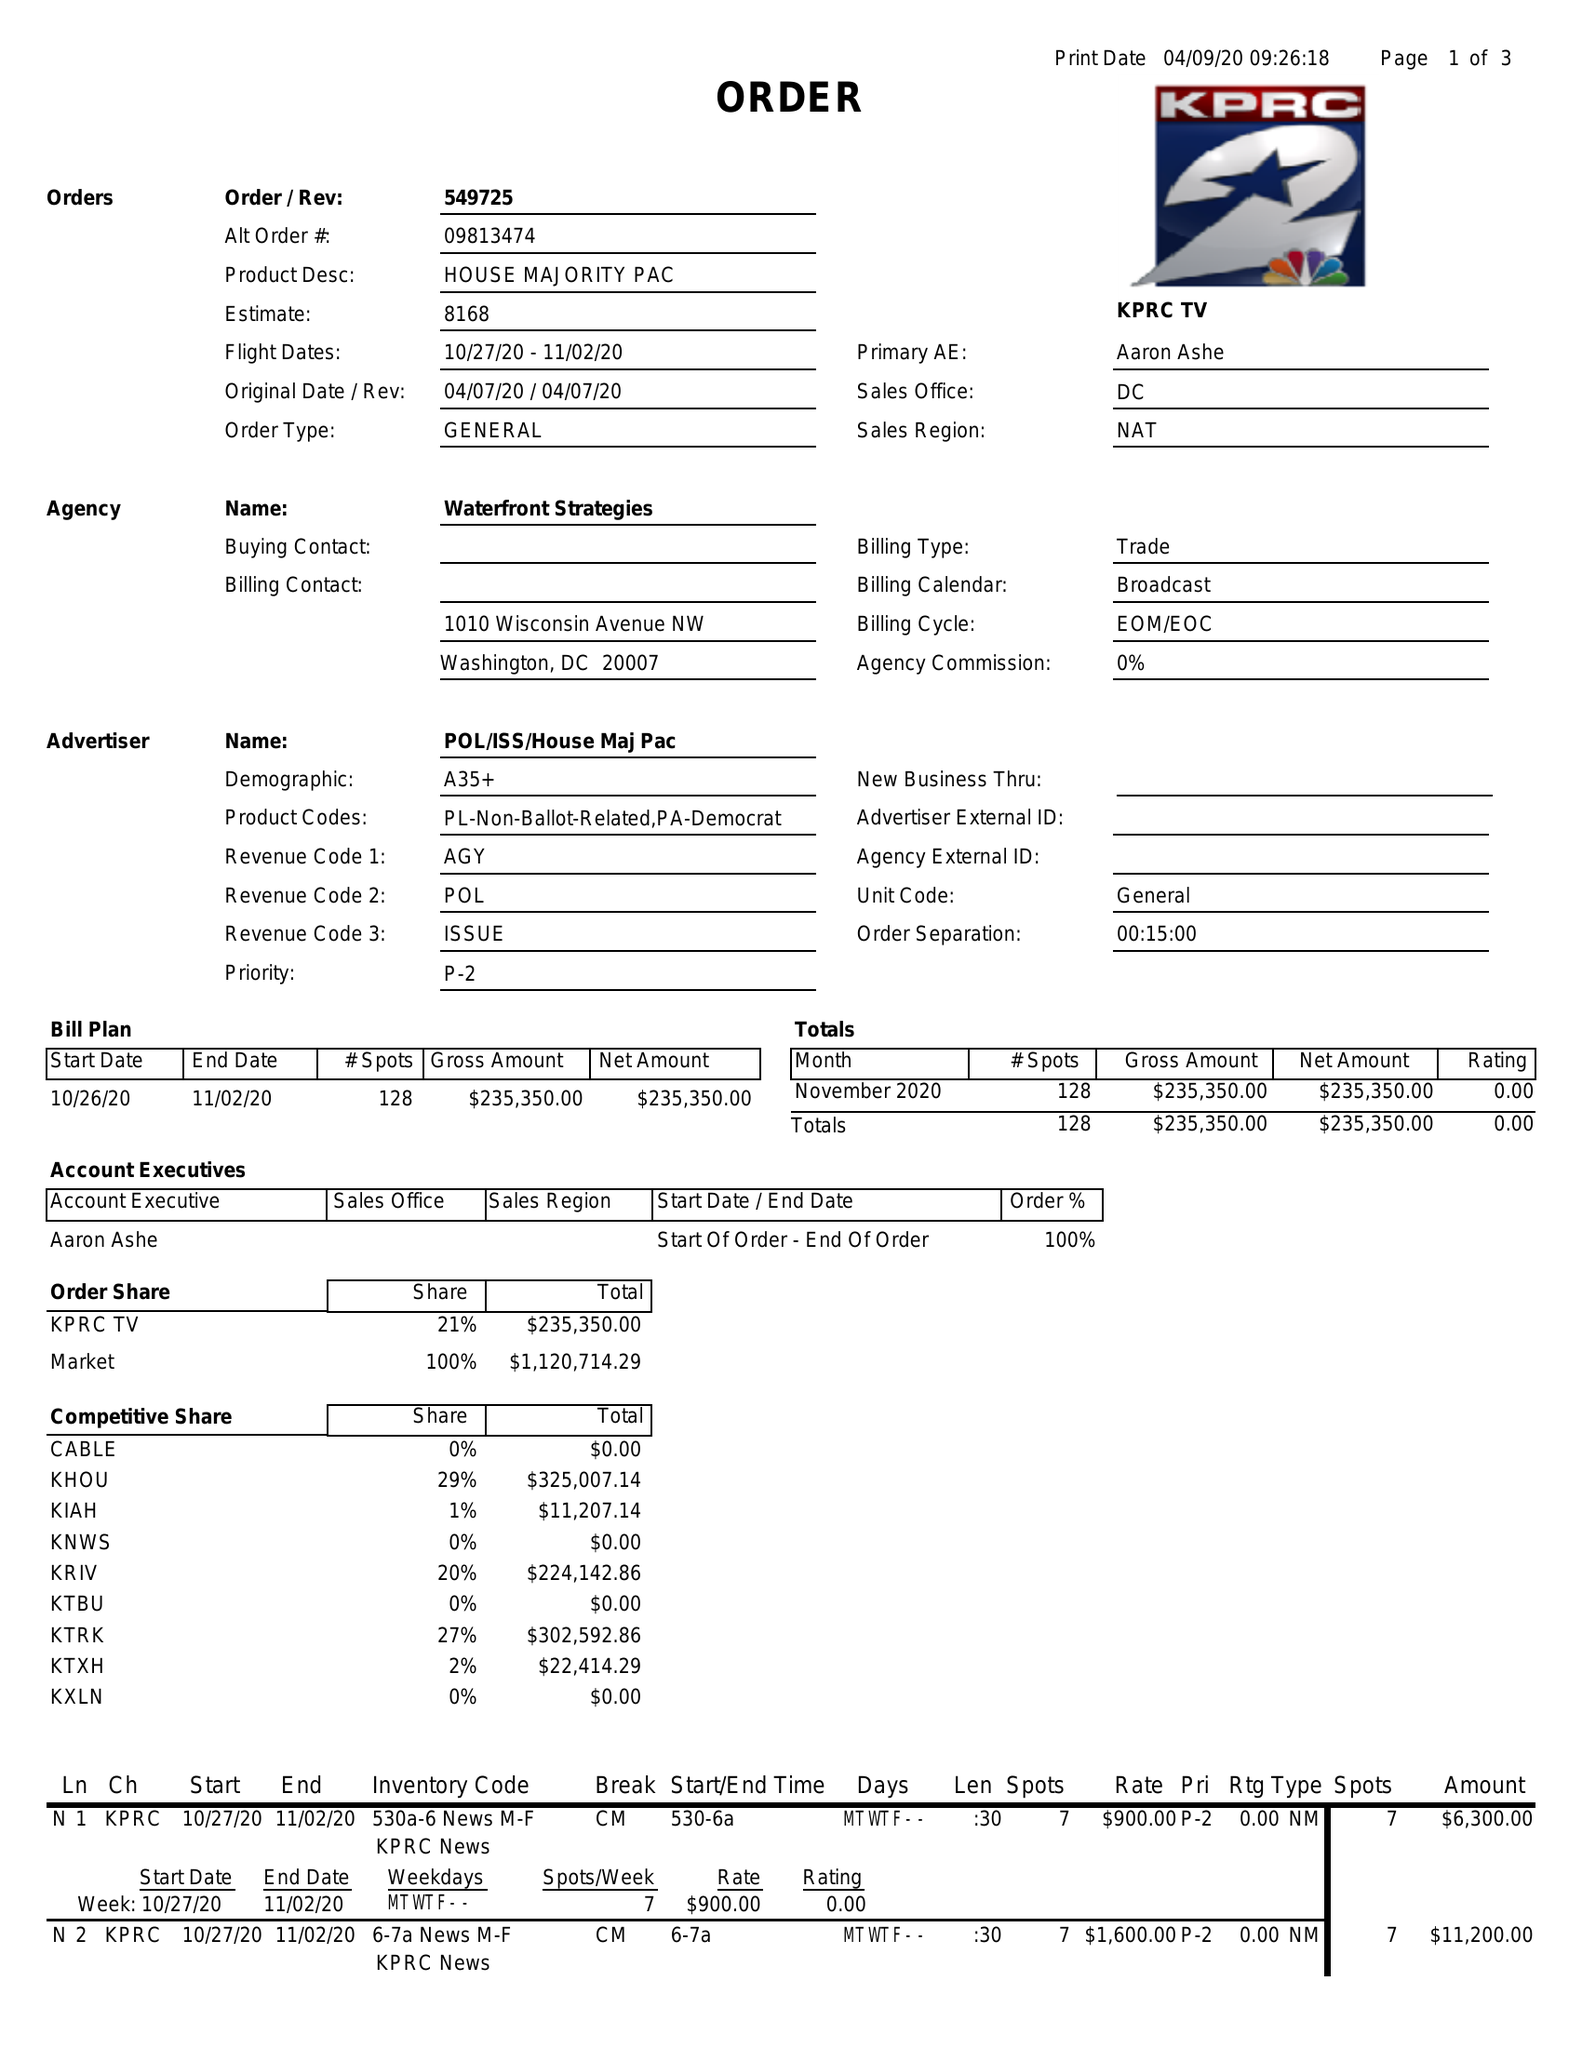What is the value for the advertiser?
Answer the question using a single word or phrase. POL/ISS/HOUSEMAJPAC 